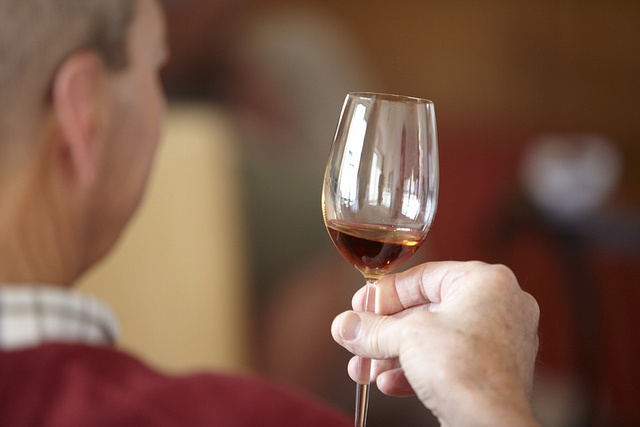Describe the objects in this image and their specific colors. I can see people in gray, maroon, and lightgray tones and wine glass in gray, darkgray, and white tones in this image. 